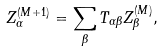Convert formula to latex. <formula><loc_0><loc_0><loc_500><loc_500>Z _ { \alpha } ^ { ( M + 1 ) } = \sum _ { \beta } T _ { \alpha \beta } Z _ { \beta } ^ { ( M ) } ,</formula> 